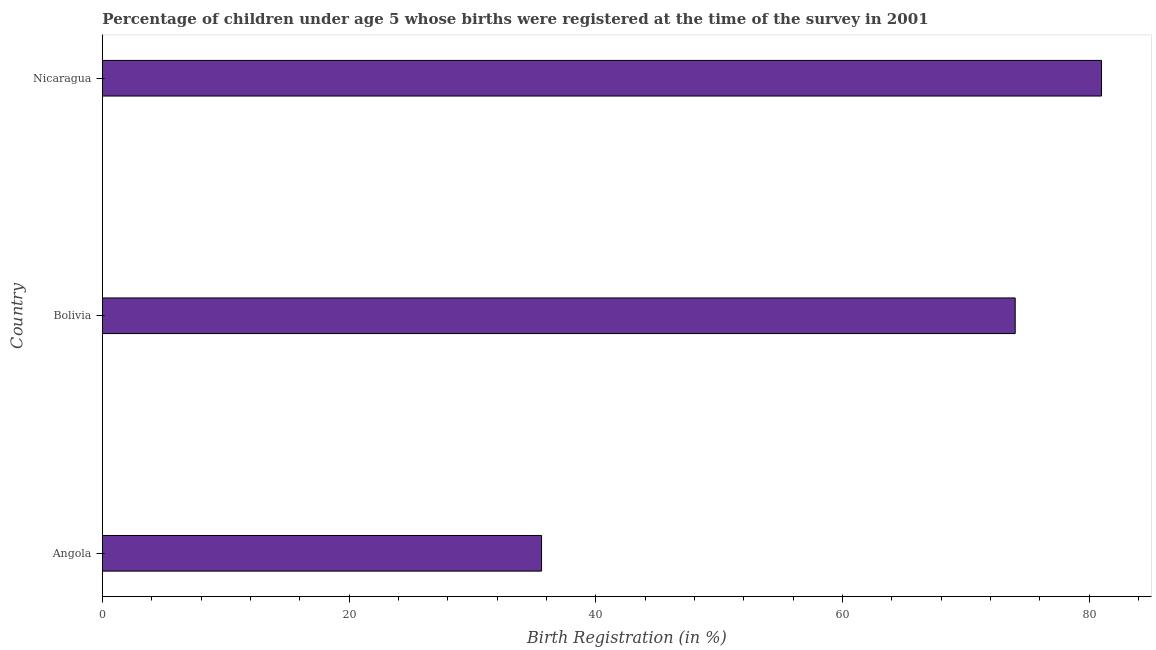Does the graph contain any zero values?
Provide a short and direct response. No. Does the graph contain grids?
Offer a terse response. No. What is the title of the graph?
Provide a succinct answer. Percentage of children under age 5 whose births were registered at the time of the survey in 2001. What is the label or title of the X-axis?
Offer a terse response. Birth Registration (in %). What is the birth registration in Angola?
Give a very brief answer. 35.6. Across all countries, what is the maximum birth registration?
Offer a very short reply. 81. Across all countries, what is the minimum birth registration?
Your answer should be very brief. 35.6. In which country was the birth registration maximum?
Make the answer very short. Nicaragua. In which country was the birth registration minimum?
Provide a succinct answer. Angola. What is the sum of the birth registration?
Provide a short and direct response. 190.6. What is the difference between the birth registration in Angola and Nicaragua?
Provide a short and direct response. -45.4. What is the average birth registration per country?
Keep it short and to the point. 63.53. What is the median birth registration?
Your response must be concise. 74. In how many countries, is the birth registration greater than 72 %?
Offer a very short reply. 2. What is the ratio of the birth registration in Angola to that in Bolivia?
Offer a very short reply. 0.48. What is the difference between the highest and the lowest birth registration?
Offer a terse response. 45.4. In how many countries, is the birth registration greater than the average birth registration taken over all countries?
Your response must be concise. 2. Are all the bars in the graph horizontal?
Make the answer very short. Yes. What is the Birth Registration (in %) in Angola?
Provide a short and direct response. 35.6. What is the Birth Registration (in %) of Bolivia?
Offer a terse response. 74. What is the Birth Registration (in %) of Nicaragua?
Give a very brief answer. 81. What is the difference between the Birth Registration (in %) in Angola and Bolivia?
Offer a very short reply. -38.4. What is the difference between the Birth Registration (in %) in Angola and Nicaragua?
Give a very brief answer. -45.4. What is the ratio of the Birth Registration (in %) in Angola to that in Bolivia?
Offer a very short reply. 0.48. What is the ratio of the Birth Registration (in %) in Angola to that in Nicaragua?
Ensure brevity in your answer.  0.44. What is the ratio of the Birth Registration (in %) in Bolivia to that in Nicaragua?
Your response must be concise. 0.91. 